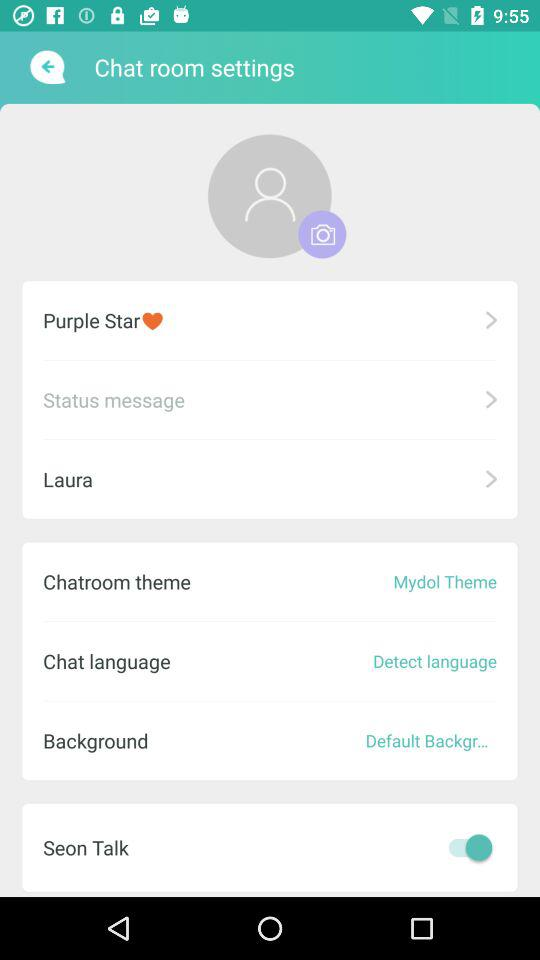What's the status of "Seon Talk"? The status is "on". 